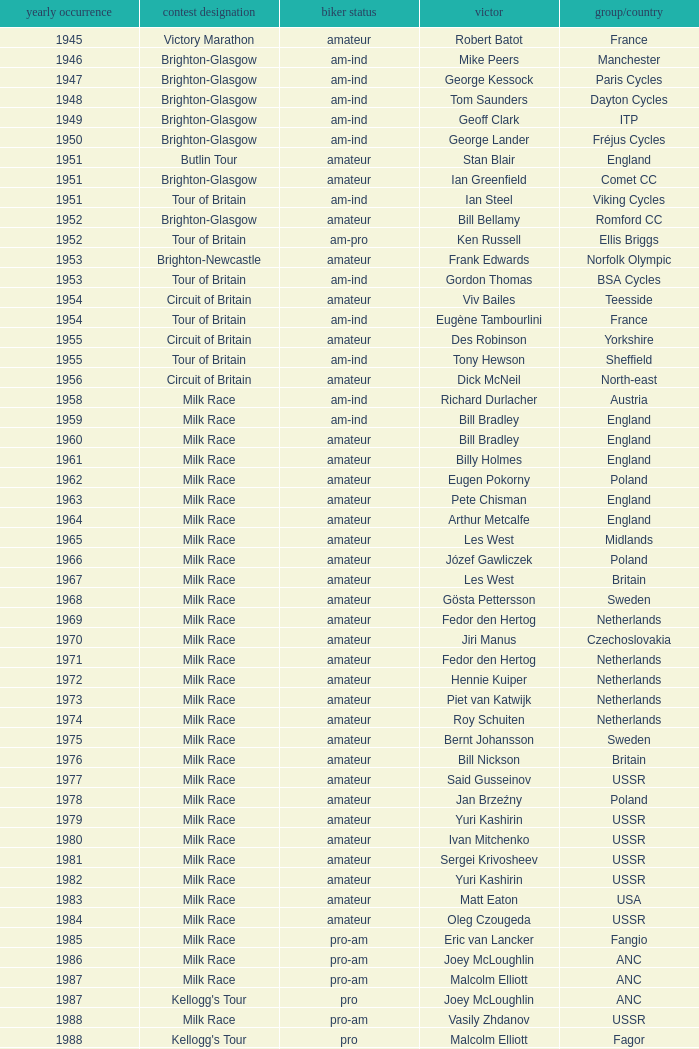What ream played later than 1958 in the kellogg's tour? ANC, Fagor, Z-Peugeot, Weinnmann-SMM, Motorola, Motorola, Motorola, Lampre. 